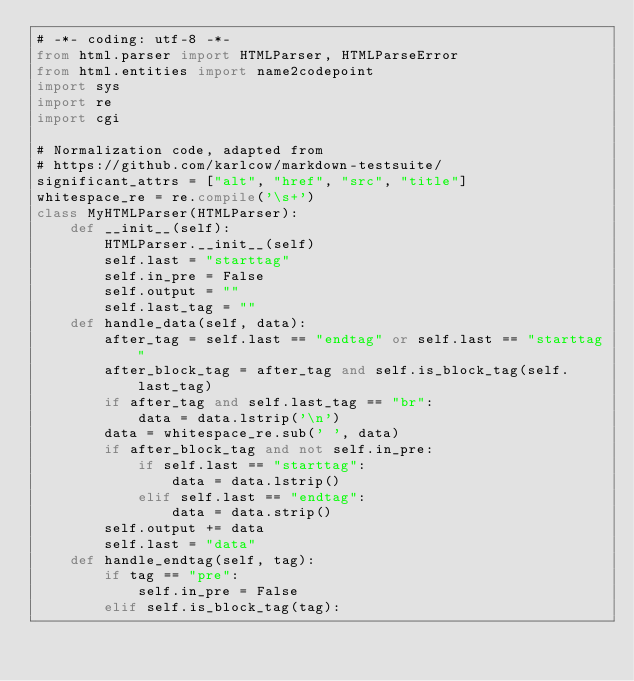<code> <loc_0><loc_0><loc_500><loc_500><_Python_># -*- coding: utf-8 -*-
from html.parser import HTMLParser, HTMLParseError
from html.entities import name2codepoint
import sys
import re
import cgi

# Normalization code, adapted from
# https://github.com/karlcow/markdown-testsuite/
significant_attrs = ["alt", "href", "src", "title"]
whitespace_re = re.compile('\s+')
class MyHTMLParser(HTMLParser):
    def __init__(self):
        HTMLParser.__init__(self)
        self.last = "starttag"
        self.in_pre = False
        self.output = ""
        self.last_tag = ""
    def handle_data(self, data):
        after_tag = self.last == "endtag" or self.last == "starttag"
        after_block_tag = after_tag and self.is_block_tag(self.last_tag)
        if after_tag and self.last_tag == "br":
            data = data.lstrip('\n')
        data = whitespace_re.sub(' ', data)
        if after_block_tag and not self.in_pre:
            if self.last == "starttag":
                data = data.lstrip()
            elif self.last == "endtag":
                data = data.strip()
        self.output += data
        self.last = "data"
    def handle_endtag(self, tag):
        if tag == "pre":
            self.in_pre = False
        elif self.is_block_tag(tag):</code> 